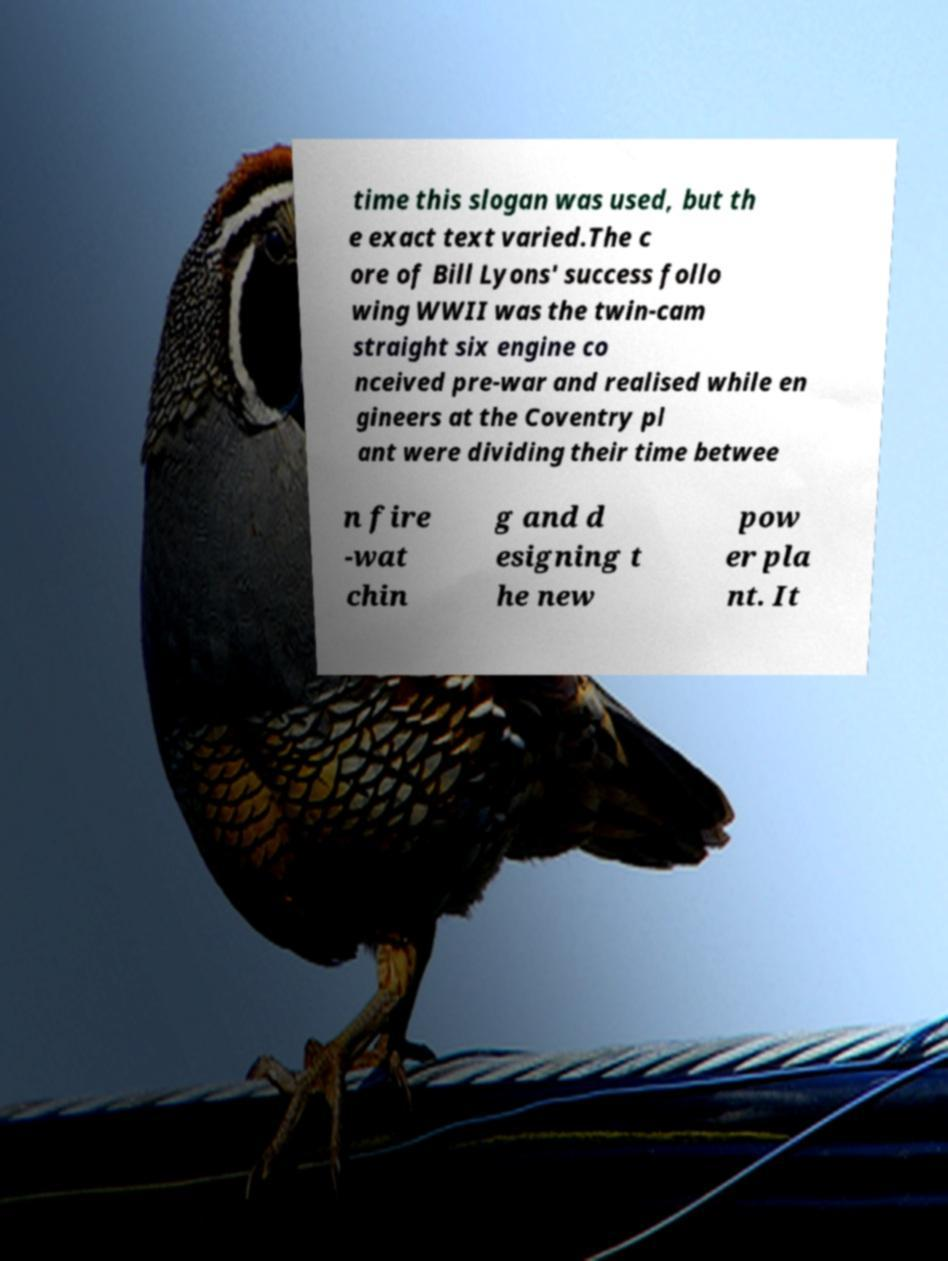For documentation purposes, I need the text within this image transcribed. Could you provide that? time this slogan was used, but th e exact text varied.The c ore of Bill Lyons' success follo wing WWII was the twin-cam straight six engine co nceived pre-war and realised while en gineers at the Coventry pl ant were dividing their time betwee n fire -wat chin g and d esigning t he new pow er pla nt. It 